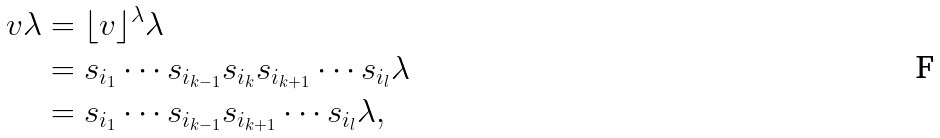Convert formula to latex. <formula><loc_0><loc_0><loc_500><loc_500>v \lambda & = \lfloor v \rfloor ^ { \lambda } \lambda \\ & = s _ { i _ { 1 } } \cdots s _ { i _ { k - 1 } } s _ { i _ { k } } s _ { i _ { k + 1 } } \cdots s _ { i _ { l } } \lambda \\ & = s _ { i _ { 1 } } \cdots s _ { i _ { k - 1 } } s _ { i _ { k + 1 } } \cdots s _ { i _ { l } } \lambda ,</formula> 